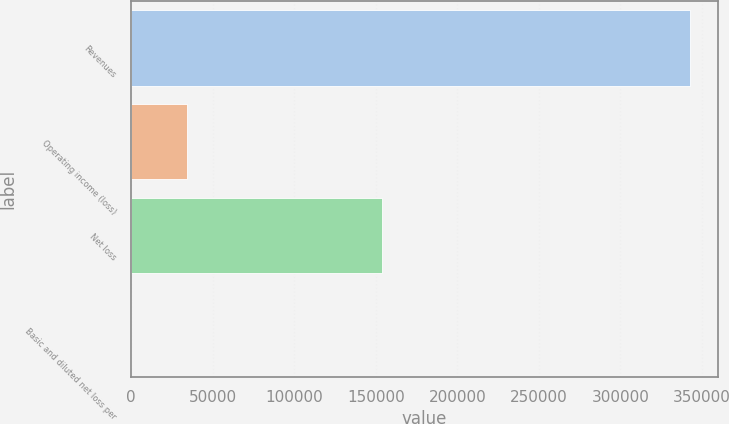Convert chart to OTSL. <chart><loc_0><loc_0><loc_500><loc_500><bar_chart><fcel>Revenues<fcel>Operating income (loss)<fcel>Net loss<fcel>Basic and diluted net loss per<nl><fcel>342441<fcel>34245.6<fcel>153967<fcel>1.69<nl></chart> 